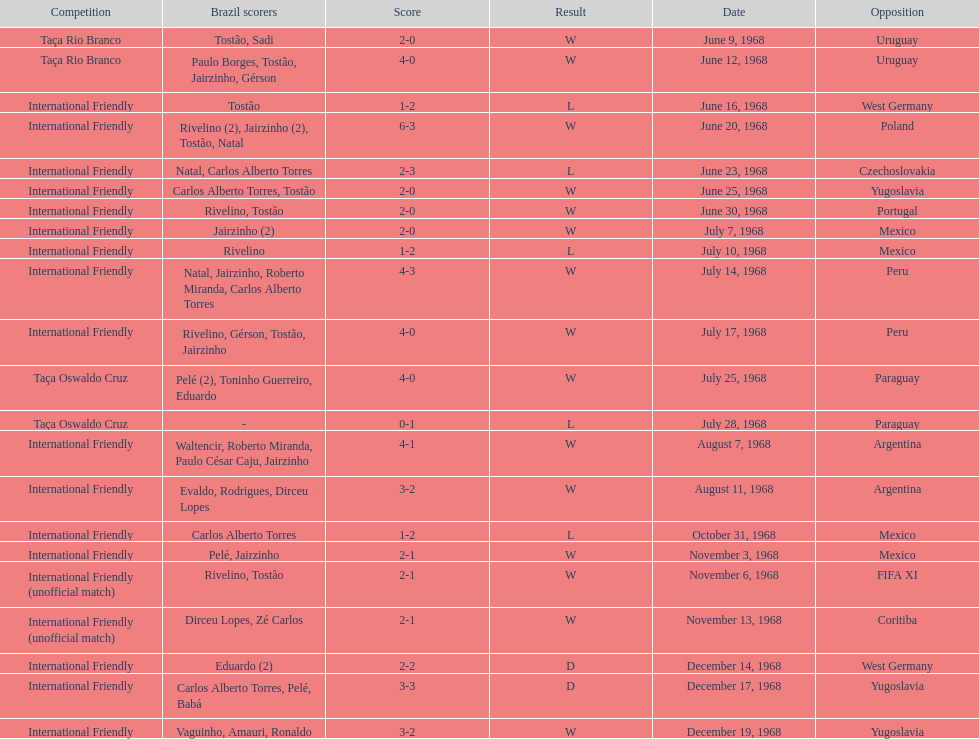How many matches are wins? 15. 